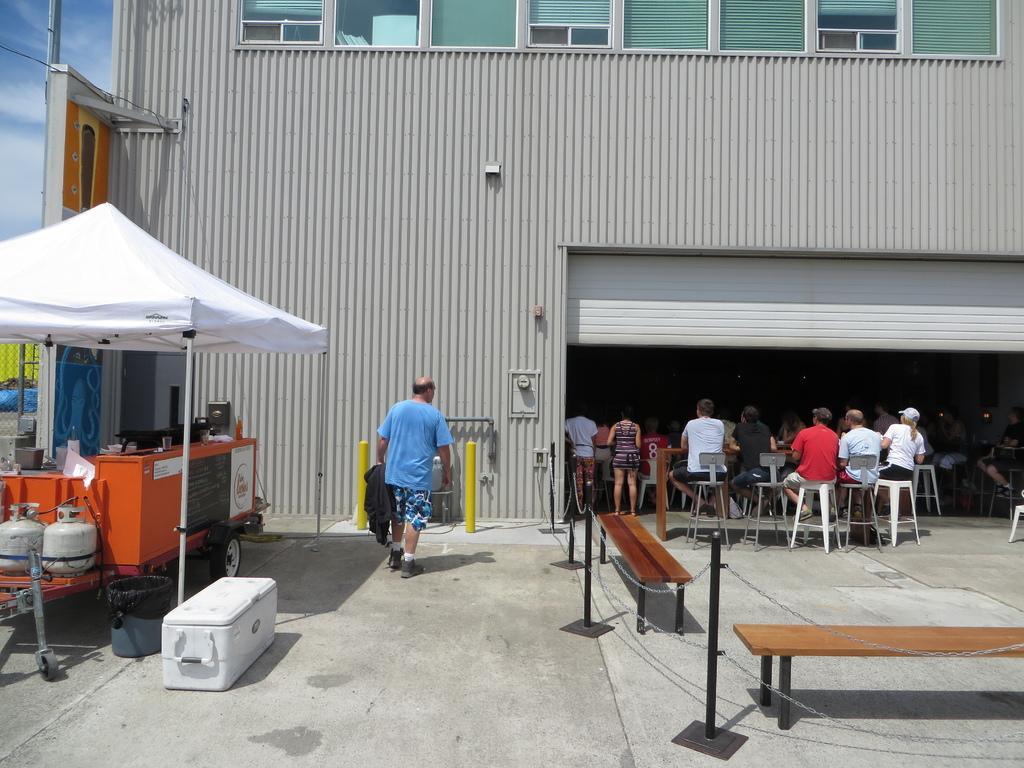Describe this image in one or two sentences. In this picture there is a man who is standing near to the tenth. Under the tent I can see the kitchen platform, cylinders and other objects. On the right I can see many peoples who are sitting on the chair. in front of them I can see the shelter and building. There are two women who are standing near to the table. In the bottom right corner I can see the benches. In the top left corner I can see the pole, sky and clouds. 